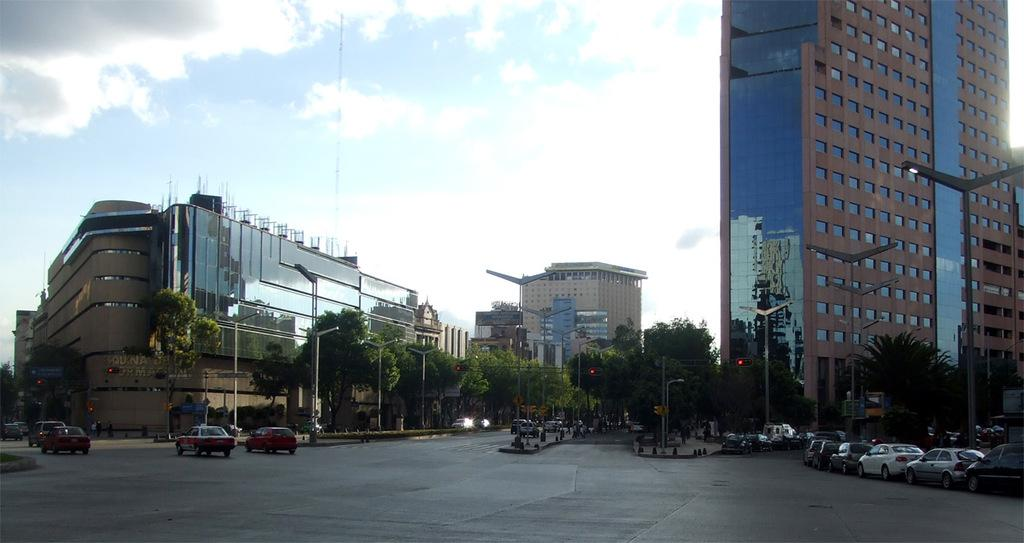What type of vehicles can be seen in the image? There are cars in the image. What natural elements are present in the image? There are trees in the image. What type of infrastructure is visible in the image? There are street lights and a road in the image. What type of man-made structures can be seen in the image? There are buildings in the image. How would you describe the sky in the image? The sky is blue with clouds. Can you tell me where the squirrel is hiding in the image? There is no squirrel present in the image. What type of legal advice is the lawyer giving in the image? There is no lawyer present in the image. 